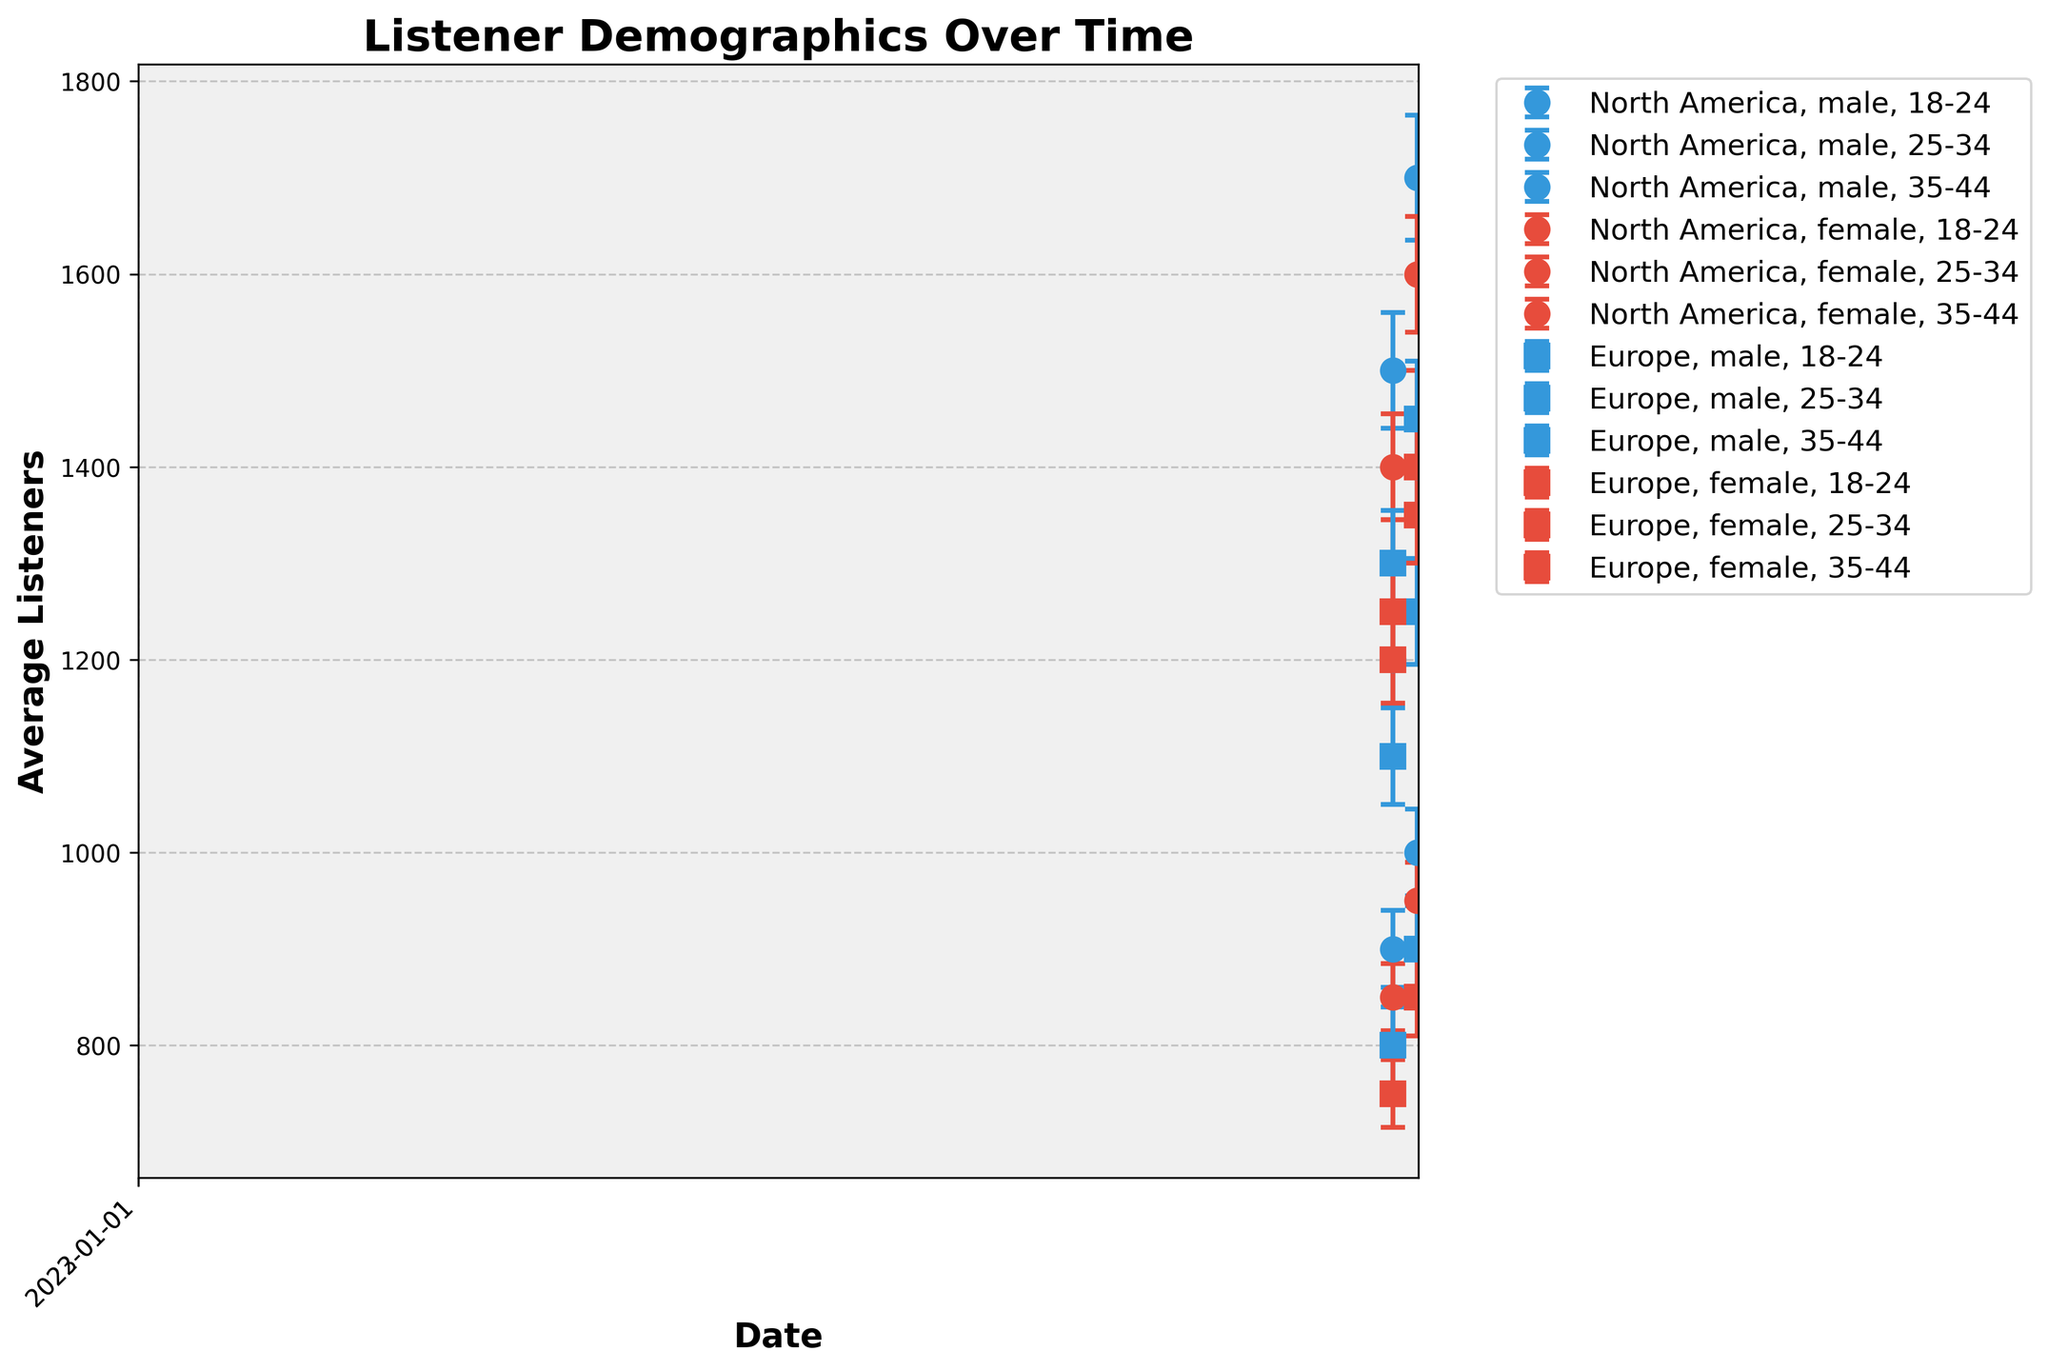What's the title of the figure? The title is usually positioned at the top of the figure and is clearly labeled to describe the content of the figure.
Answer: Listener Demographics Over Time What information is shown on the x-axis? The x-axis typically shows the time points at which the data was collected. In this figure, it represents dates.
Answer: Date What information is shown on the y-axis? The y-axis represents the variable being measured, which, in this case, is the average number of listeners.
Answer: Average Listeners Which elements of the plot help in showing the level of uncertainty in the data? Error bars on the scatter points provide a visual representation of the error margin or level of uncertainty in the data.
Answer: Error bars How does the average number of listeners for the 18-24 year old males in North America change from 2022 to 2023? First, identify the average listeners for 18-24 males in North America for both years. In 2022, it is 1200, and in 2023, it is 1400. The change is calculated as 1400 - 1200 = 200.
Answer: Increases by 200 Between 2022 and 2023, which age group in North America had the largest increase in average listeners for males? Compare the increments for all male age groups in North America: 
   - 18-24: 1400 - 1200 = 200 
   - 25-34: 1700 - 1500 = 200 
   - 35-44: 1000 - 900 = 100. 
So, the 18-24 and 25-34 age groups both have an increase of 200, which are the largest.
Answer: 18-24 and 25-34 Compare the error margins for 25-34 year old females in Europe in 2022 and 2023. Which year had a higher uncertainty? Identify the error margins for 25-34 females in Europe. In 2022, it is 50, and in 2023, it is 55. The year 2023 has the higher uncertainty.
Answer: 2023 Are the average listeners higher for 25-34 males or 25-34 females in Europe in 2023? Look at the average listeners for 25-34 groups in Europe in 2023. For males, it's 1450, and for females, it's 1400. Males have higher average listeners.
Answer: Males Do any age groups in North America show a decrease in average listeners from 2022 to 2023? Check the differences for each age group in North America. All age groups show an increase:
   - 18-24: 1400 - 1200 = 200 
   - 25-34: 1700 - 1500 = 200 
   - 35-44: 1000 - 900 = 100.
No age group shows a decrease.
Answer: No 